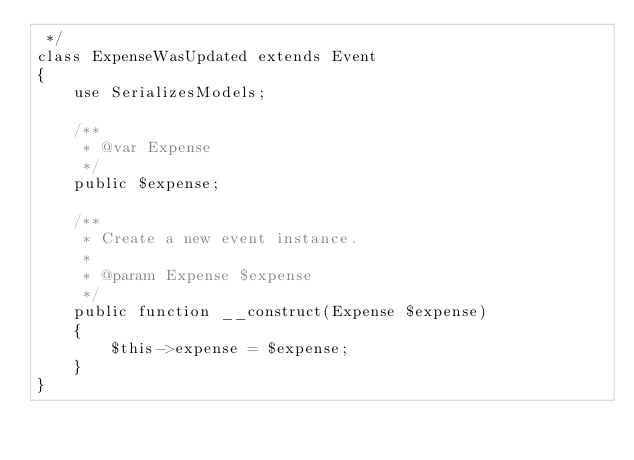Convert code to text. <code><loc_0><loc_0><loc_500><loc_500><_PHP_> */
class ExpenseWasUpdated extends Event
{
    use SerializesModels;

    /**
     * @var Expense
     */
    public $expense;

    /**
     * Create a new event instance.
     *
     * @param Expense $expense
     */
    public function __construct(Expense $expense)
    {
        $this->expense = $expense;
    }
}
</code> 